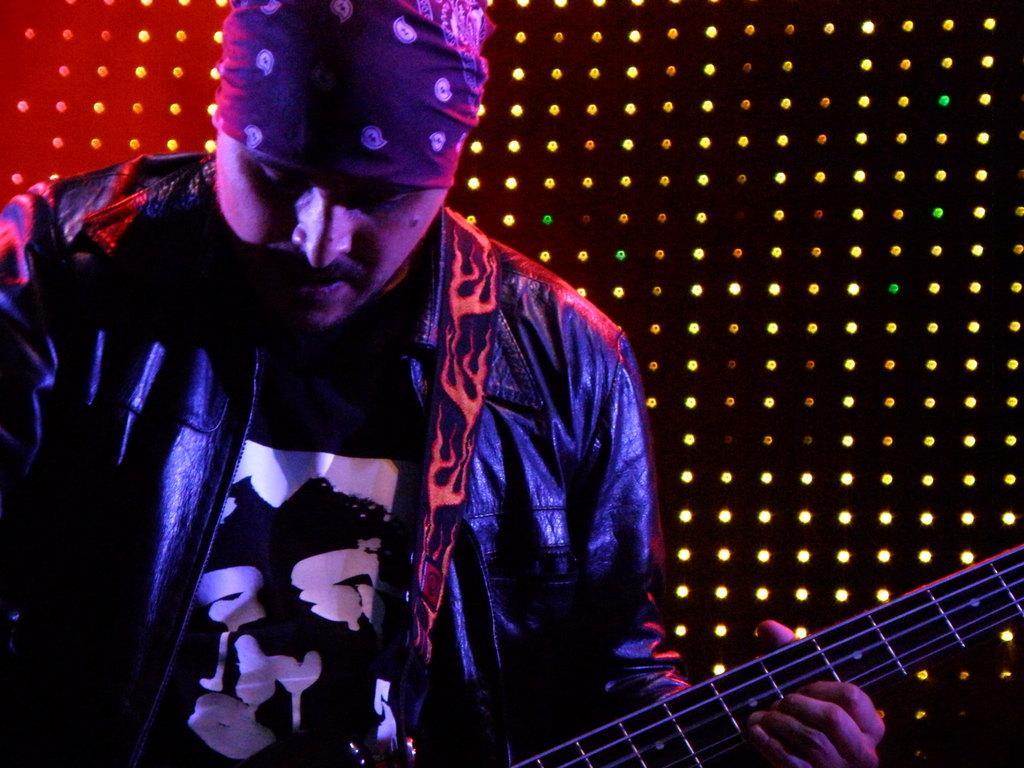Describe this image in one or two sentences. This is a picture of a man in a leather black jacket. The man holding a guitar and the background is a black with lights. 